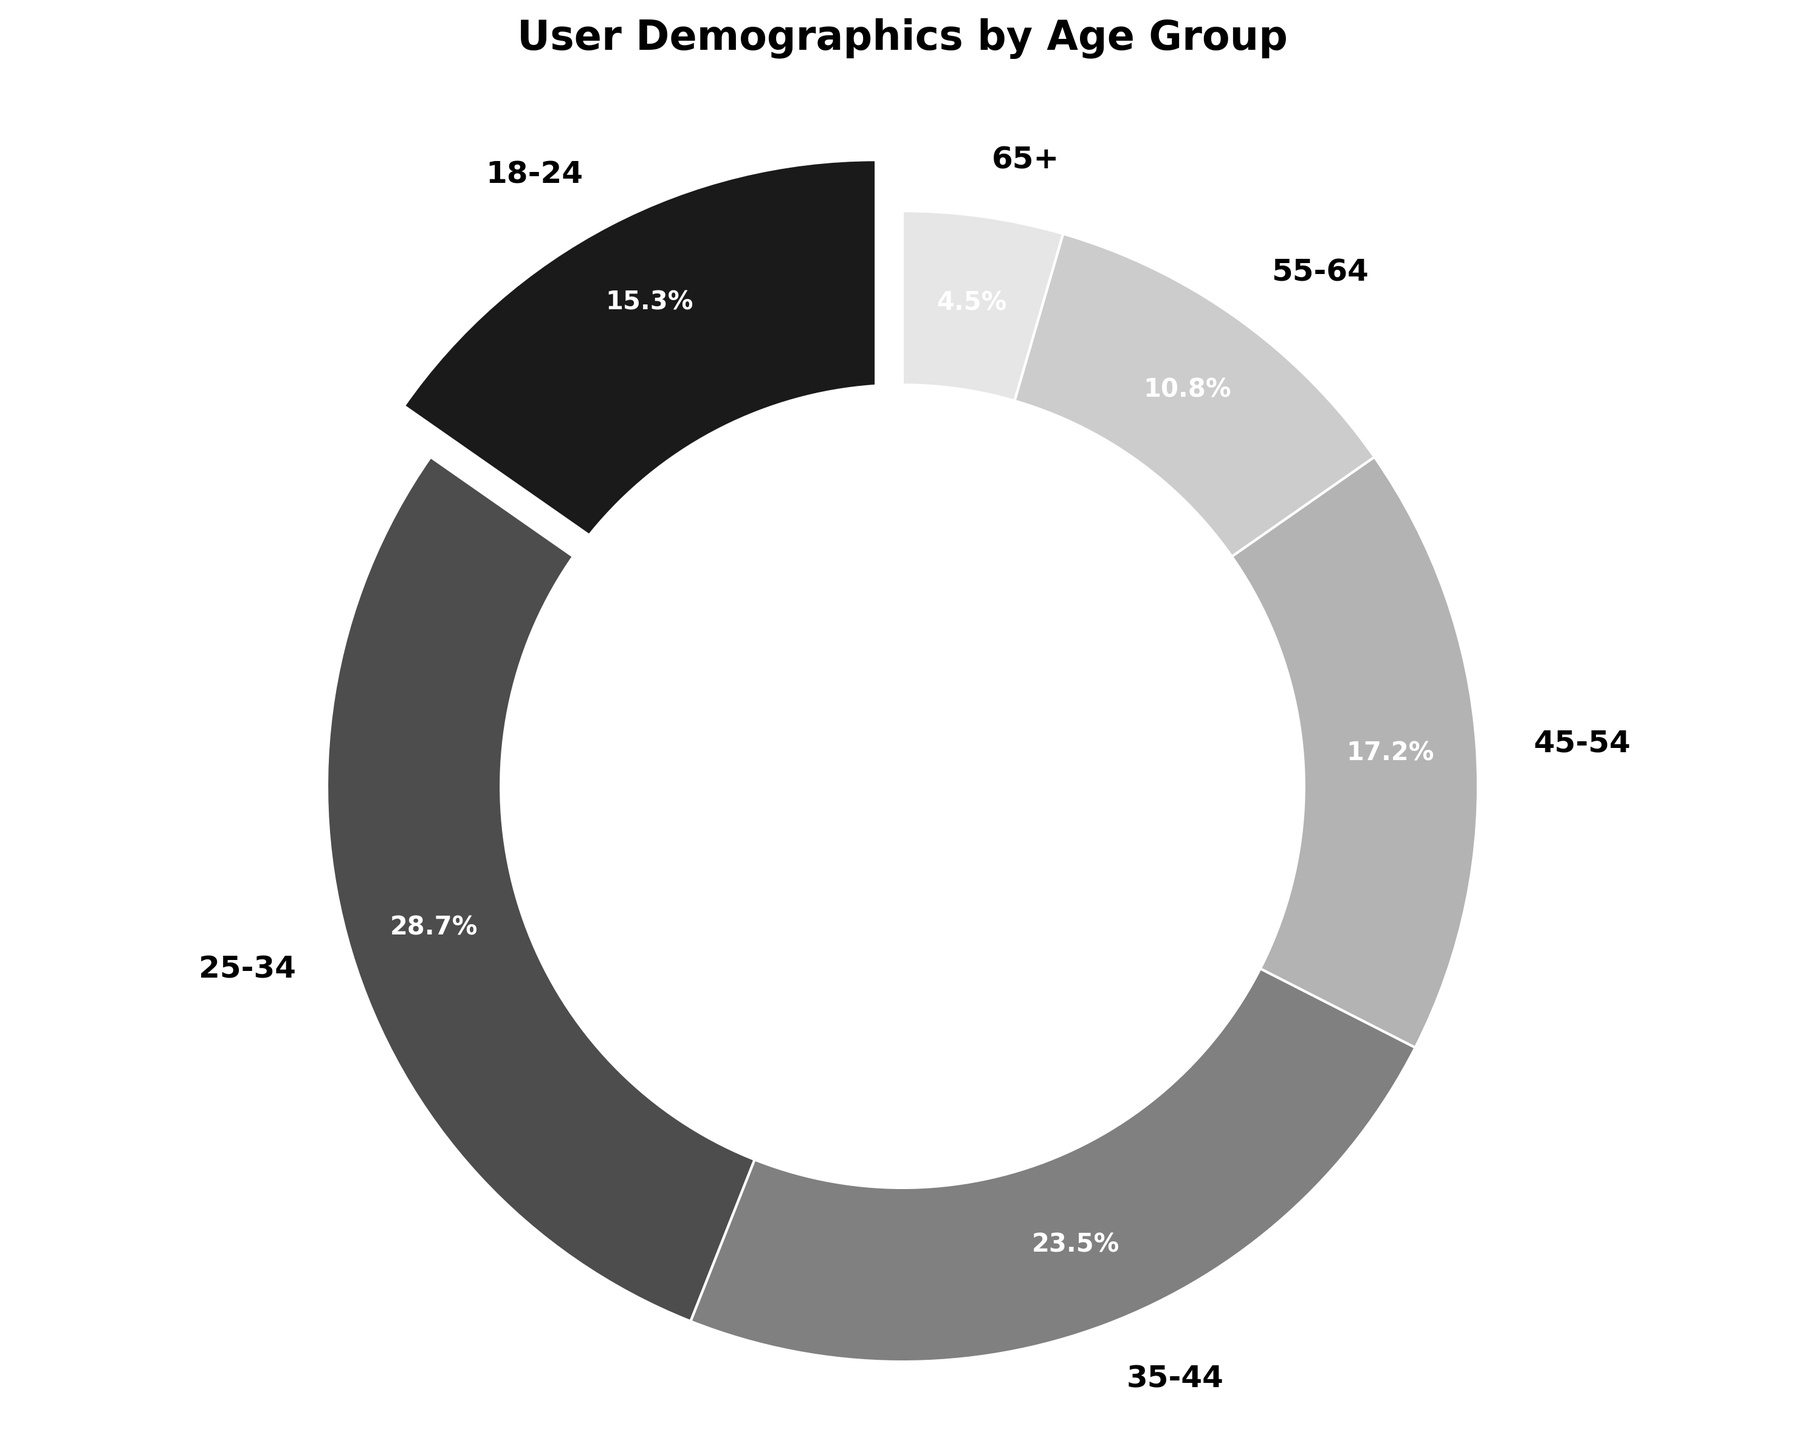What percentage of users are aged 25-34? By looking at the pie chart, locate the segment for age group 25-34. The percentage label for this segment is displayed on the chart.
Answer: 28.7% Which age group has the smallest percentage of users? Examine the pie chart and identify the age group with the smallest wedge or segment. The age group with the smallest percentage should be the smallest segment.
Answer: 65+ What is the combined percentage of users aged 45-54 and 55-64? Find the percentages for the age groups 45-54 and 55-64 in the pie chart. Sum these two percentages: 17.2% (45-54) + 10.8% (55-64).
Answer: 28% Compare the percentage of users aged 35-44 to users aged 55-64. Which group is larger? Locate the percentage for the age groups 35-44 and 55-64 in the pie chart. Compare the two values: 35-44 is 23.5% and 55-64 is 10.8%. Determine which is larger.
Answer: 35-44 What is the total percentage of users below 35 years old? Identify and sum the percentages for the age groups under 35: 18-24 and 25-34. Add these two percentages: 15.3% (18-24) + 28.7% (25-34).
Answer: 44% What is the difference in percentage between users aged 18-24 and 55-64? Find the percentages for age groups 18-24 and 55-64 in the pie chart. Subtract the smaller percentage from the larger one: 15.3% (18-24) - 10.8% (55-64).
Answer: 4.5% Which age group has a percentage closest to 20%? Examine the chart and identify the age group whose percentage is nearest to 20%. Age group 35-44 has 23.5%, which is the closest.
Answer: 35-44 Rank each age group from highest to lowest percentage. Look at the percentages on the pie chart for each age group. List them in descending order: 25-34 (28.7%), 35-44 (23.5%), 45-54 (17.2%), 18-24 (15.3%), 55-64 (10.8%), 65+ (4.5%).
Answer: 25-34, 35-44, 45-54, 18-24, 55-64, 65+ What is the average percentage of the age groups 35-44, 45-54, and 55-64? Find the percentages for the age groups 35-44, 45-54, and 55-64: 23.5%, 17.2%, and 10.8%. Calculate the average by adding these percentages and dividing by 3: (23.5 + 17.2 + 10.8) / 3.
Answer: 17.17% How many more percentage points does the largest age group have compared to the smallest? Identify the largest and smallest percentages from the pie chart: largest (25-34, 28.7%) and smallest (65+, 4.5%). Subtract the smallest from the largest: 28.7% - 4.5%.
Answer: 24.2% 